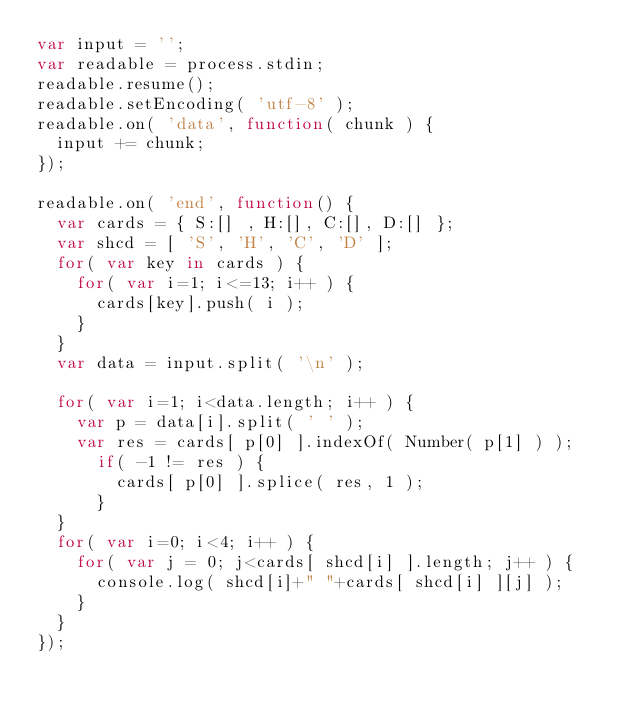Convert code to text. <code><loc_0><loc_0><loc_500><loc_500><_JavaScript_>var input = '';
var readable = process.stdin;
readable.resume();
readable.setEncoding( 'utf-8' );
readable.on( 'data', function( chunk ) {
  input += chunk;
});

readable.on( 'end', function() {
  var cards = { S:[] , H:[], C:[], D:[] };
  var shcd = [ 'S', 'H', 'C', 'D' ];
  for( var key in cards ) {
    for( var i=1; i<=13; i++ ) {
      cards[key].push( i );
    }
  }
  var data = input.split( '\n' );
 
  for( var i=1; i<data.length; i++ ) {
    var p = data[i].split( ' ' );
    var res = cards[ p[0] ].indexOf( Number( p[1] ) );
      if( -1 != res ) {
        cards[ p[0] ].splice( res, 1 );
      }
  }
  for( var i=0; i<4; i++ ) {
    for( var j = 0; j<cards[ shcd[i] ].length; j++ ) {
      console.log( shcd[i]+" "+cards[ shcd[i] ][j] );
    }
  }
});</code> 